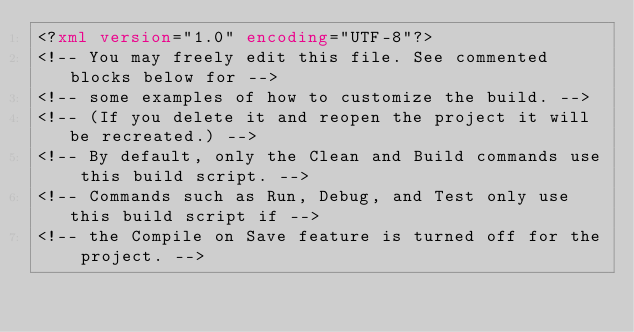<code> <loc_0><loc_0><loc_500><loc_500><_XML_><?xml version="1.0" encoding="UTF-8"?>
<!-- You may freely edit this file. See commented blocks below for -->
<!-- some examples of how to customize the build. -->
<!-- (If you delete it and reopen the project it will be recreated.) -->
<!-- By default, only the Clean and Build commands use this build script. -->
<!-- Commands such as Run, Debug, and Test only use this build script if -->
<!-- the Compile on Save feature is turned off for the project. --></code> 